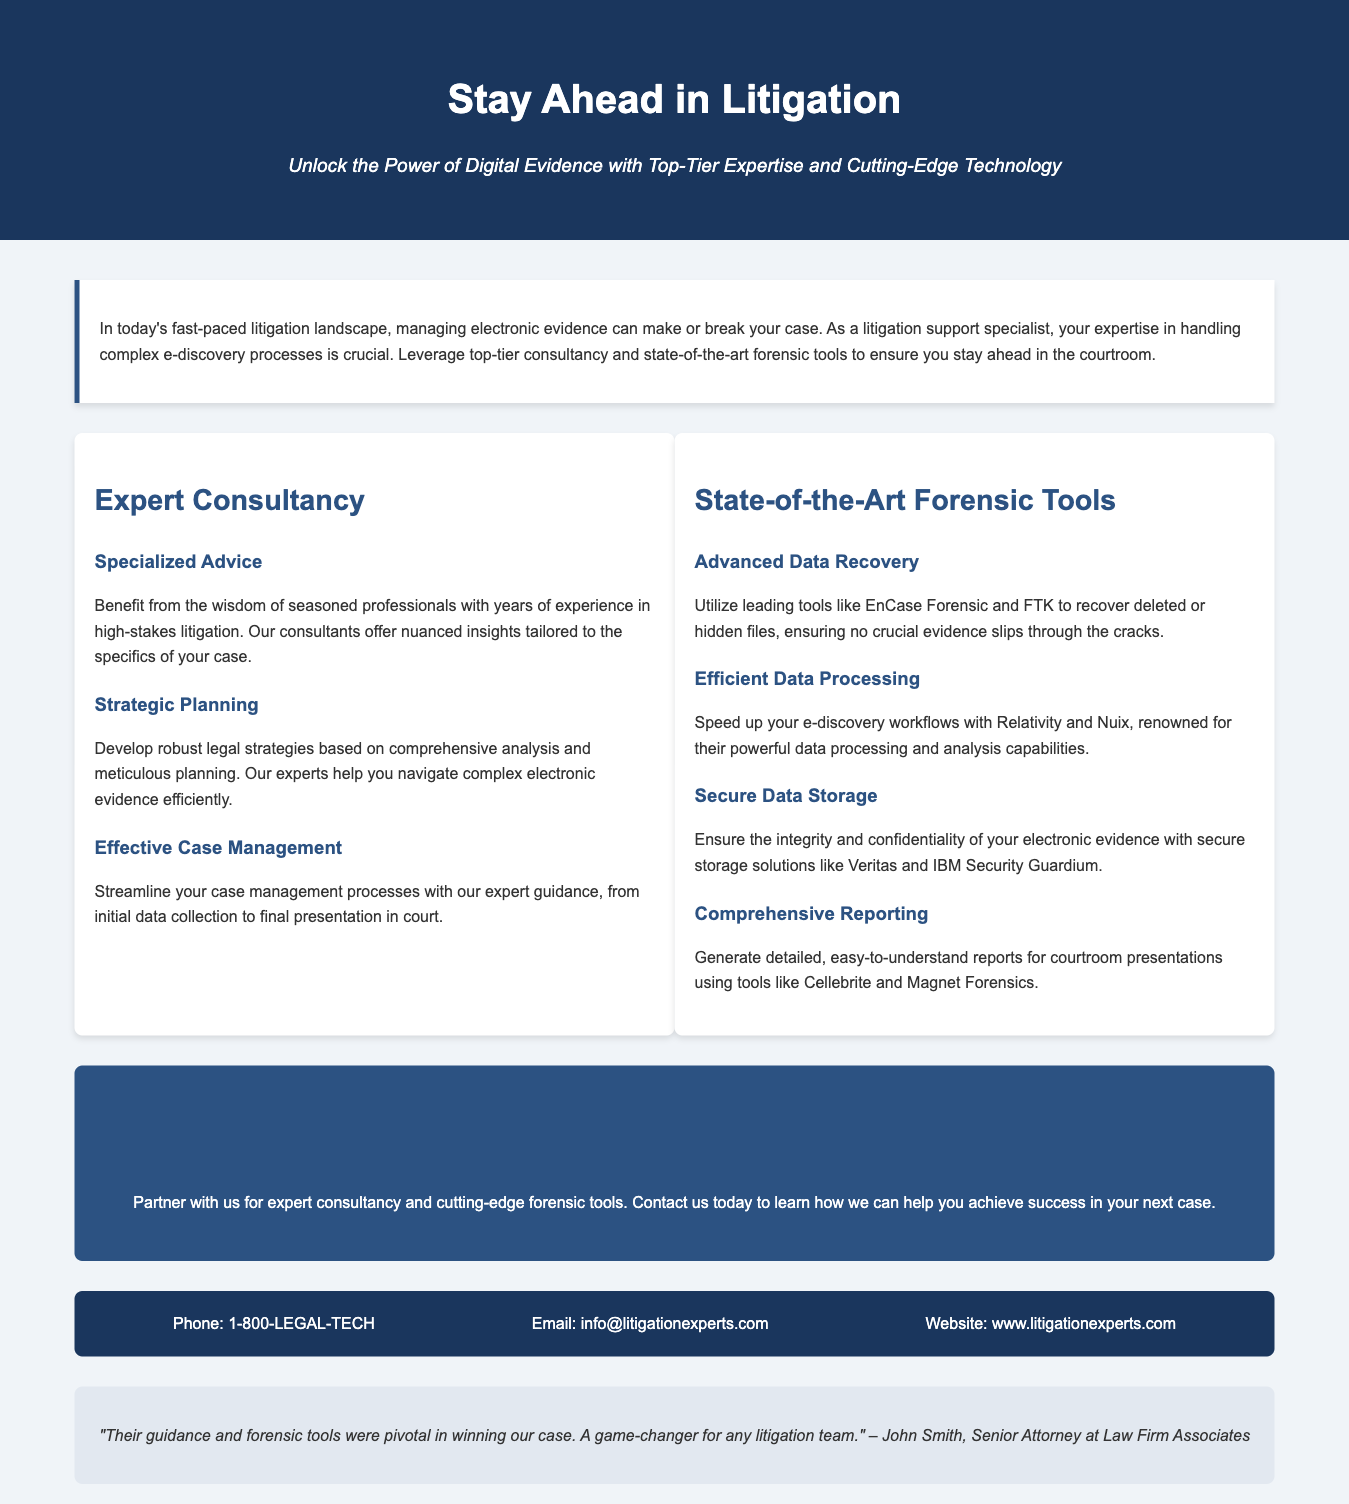What is the main title of the advertisement? The main title of the advertisement is prominently displayed at the top of the document.
Answer: Stay Ahead in Litigation What is the subtitle of the advertisement? The subtitle provides additional context about the service being offered and is located beneath the main title.
Answer: Unlock the Power of Digital Evidence with Top-Tier Expertise and Cutting-Edge Technology What is the phone number for contacting the service? The phone number is listed in the contact information section of the document.
Answer: 1-800-LEGAL-TECH Which forensic tool is mentioned for advanced data recovery? The document specifies tools used for recovering data and highlights one in particular.
Answer: EnCase Forensic What does the testimonial say about the service? The testimonial provides feedback from a client and highlights the impact of the services offered.
Answer: Their guidance and forensic tools were pivotal in winning our case. A game-changer for any litigation team What is one of the benefits of expert consultancy mentioned? The benefits section describes several advantages of consultancy, requiring insight from this part of the document.
Answer: Specialized Advice How does the advertisement suggest handling electronic evidence? This question addresses the overall recommendation provided in the call to action of the advertisement.
Answer: Partner with us for expert consultancy and cutting-edge forensic tools What is one of the tools used for comprehensive reporting? The benefits section lists various tools used for reporting, and this question seeks a specific example.
Answer: Cellebrite How many types of forensic tools are discussed in the advertisement? The document outlines various categories of services and tools, which requires counting the distinct sections.
Answer: Four 